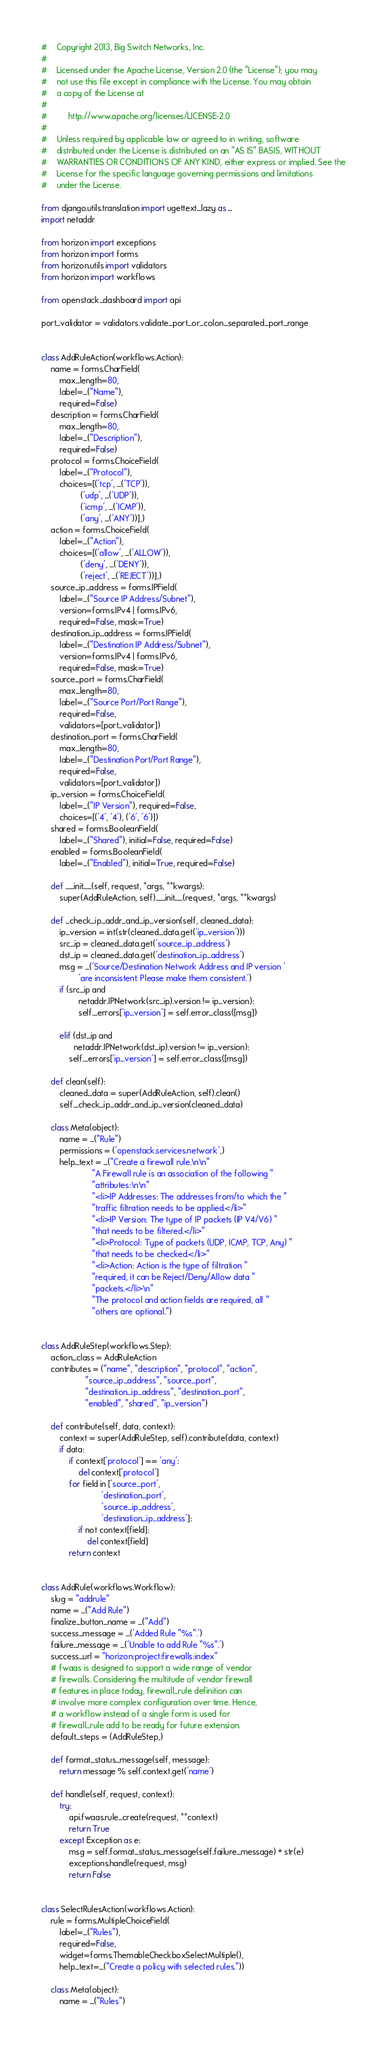<code> <loc_0><loc_0><loc_500><loc_500><_Python_>#    Copyright 2013, Big Switch Networks, Inc.
#
#    Licensed under the Apache License, Version 2.0 (the "License"); you may
#    not use this file except in compliance with the License. You may obtain
#    a copy of the License at
#
#         http://www.apache.org/licenses/LICENSE-2.0
#
#    Unless required by applicable law or agreed to in writing, software
#    distributed under the License is distributed on an "AS IS" BASIS, WITHOUT
#    WARRANTIES OR CONDITIONS OF ANY KIND, either express or implied. See the
#    License for the specific language governing permissions and limitations
#    under the License.

from django.utils.translation import ugettext_lazy as _
import netaddr

from horizon import exceptions
from horizon import forms
from horizon.utils import validators
from horizon import workflows

from openstack_dashboard import api

port_validator = validators.validate_port_or_colon_separated_port_range


class AddRuleAction(workflows.Action):
    name = forms.CharField(
        max_length=80,
        label=_("Name"),
        required=False)
    description = forms.CharField(
        max_length=80,
        label=_("Description"),
        required=False)
    protocol = forms.ChoiceField(
        label=_("Protocol"),
        choices=[('tcp', _('TCP')),
                 ('udp', _('UDP')),
                 ('icmp', _('ICMP')),
                 ('any', _('ANY'))],)
    action = forms.ChoiceField(
        label=_("Action"),
        choices=[('allow', _('ALLOW')),
                 ('deny', _('DENY')),
                 ('reject', _('REJECT'))],)
    source_ip_address = forms.IPField(
        label=_("Source IP Address/Subnet"),
        version=forms.IPv4 | forms.IPv6,
        required=False, mask=True)
    destination_ip_address = forms.IPField(
        label=_("Destination IP Address/Subnet"),
        version=forms.IPv4 | forms.IPv6,
        required=False, mask=True)
    source_port = forms.CharField(
        max_length=80,
        label=_("Source Port/Port Range"),
        required=False,
        validators=[port_validator])
    destination_port = forms.CharField(
        max_length=80,
        label=_("Destination Port/Port Range"),
        required=False,
        validators=[port_validator])
    ip_version = forms.ChoiceField(
        label=_("IP Version"), required=False,
        choices=[('4', '4'), ('6', '6')])
    shared = forms.BooleanField(
        label=_("Shared"), initial=False, required=False)
    enabled = forms.BooleanField(
        label=_("Enabled"), initial=True, required=False)

    def __init__(self, request, *args, **kwargs):
        super(AddRuleAction, self).__init__(request, *args, **kwargs)

    def _check_ip_addr_and_ip_version(self, cleaned_data):
        ip_version = int(str(cleaned_data.get('ip_version')))
        src_ip = cleaned_data.get('source_ip_address')
        dst_ip = cleaned_data.get('destination_ip_address')
        msg = _('Source/Destination Network Address and IP version '
                'are inconsistent. Please make them consistent.')
        if (src_ip and
                netaddr.IPNetwork(src_ip).version != ip_version):
                self._errors['ip_version'] = self.error_class([msg])

        elif (dst_ip and
              netaddr.IPNetwork(dst_ip).version != ip_version):
            self._errors['ip_version'] = self.error_class([msg])

    def clean(self):
        cleaned_data = super(AddRuleAction, self).clean()
        self._check_ip_addr_and_ip_version(cleaned_data)

    class Meta(object):
        name = _("Rule")
        permissions = ('openstack.services.network',)
        help_text = _("Create a firewall rule.\n\n"
                      "A Firewall rule is an association of the following "
                      "attributes:\n\n"
                      "<li>IP Addresses: The addresses from/to which the "
                      "traffic filtration needs to be applied.</li>"
                      "<li>IP Version: The type of IP packets (IP V4/V6) "
                      "that needs to be filtered.</li>"
                      "<li>Protocol: Type of packets (UDP, ICMP, TCP, Any) "
                      "that needs to be checked.</li>"
                      "<li>Action: Action is the type of filtration "
                      "required, it can be Reject/Deny/Allow data "
                      "packets.</li>\n"
                      "The protocol and action fields are required, all "
                      "others are optional.")


class AddRuleStep(workflows.Step):
    action_class = AddRuleAction
    contributes = ("name", "description", "protocol", "action",
                   "source_ip_address", "source_port",
                   "destination_ip_address", "destination_port",
                   "enabled", "shared", "ip_version")

    def contribute(self, data, context):
        context = super(AddRuleStep, self).contribute(data, context)
        if data:
            if context['protocol'] == 'any':
                del context['protocol']
            for field in ['source_port',
                          'destination_port',
                          'source_ip_address',
                          'destination_ip_address']:
                if not context[field]:
                    del context[field]
            return context


class AddRule(workflows.Workflow):
    slug = "addrule"
    name = _("Add Rule")
    finalize_button_name = _("Add")
    success_message = _('Added Rule "%s".')
    failure_message = _('Unable to add Rule "%s".')
    success_url = "horizon:project:firewalls:index"
    # fwaas is designed to support a wide range of vendor
    # firewalls. Considering the multitude of vendor firewall
    # features in place today, firewall_rule definition can
    # involve more complex configuration over time. Hence,
    # a workflow instead of a single form is used for
    # firewall_rule add to be ready for future extension.
    default_steps = (AddRuleStep,)

    def format_status_message(self, message):
        return message % self.context.get('name')

    def handle(self, request, context):
        try:
            api.fwaas.rule_create(request, **context)
            return True
        except Exception as e:
            msg = self.format_status_message(self.failure_message) + str(e)
            exceptions.handle(request, msg)
            return False


class SelectRulesAction(workflows.Action):
    rule = forms.MultipleChoiceField(
        label=_("Rules"),
        required=False,
        widget=forms.ThemableCheckboxSelectMultiple(),
        help_text=_("Create a policy with selected rules."))

    class Meta(object):
        name = _("Rules")</code> 